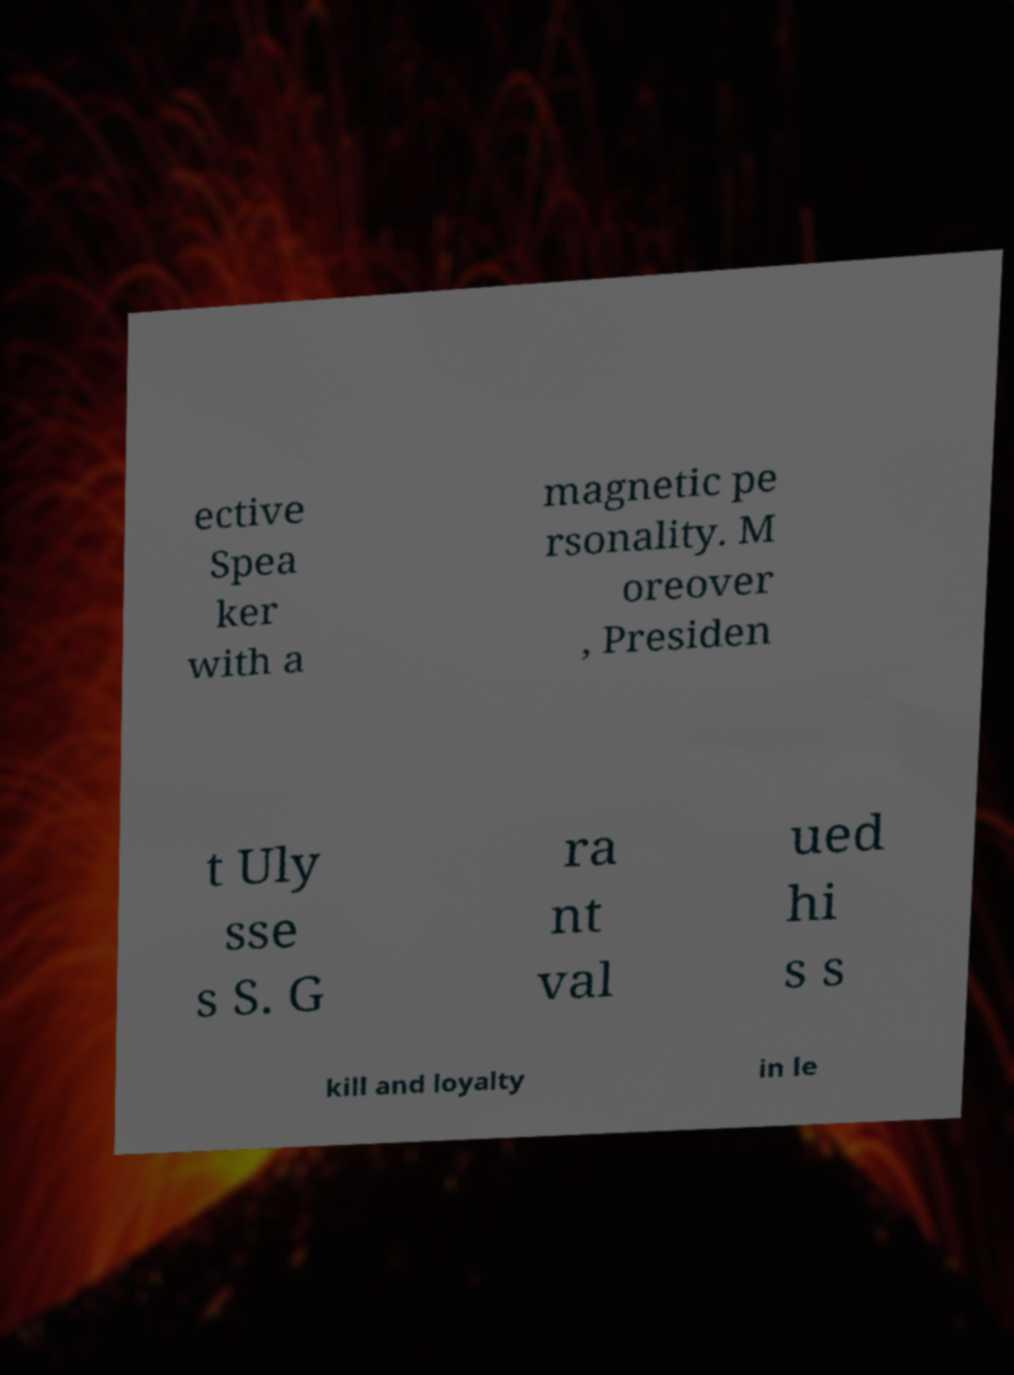Could you extract and type out the text from this image? ective Spea ker with a magnetic pe rsonality. M oreover , Presiden t Uly sse s S. G ra nt val ued hi s s kill and loyalty in le 